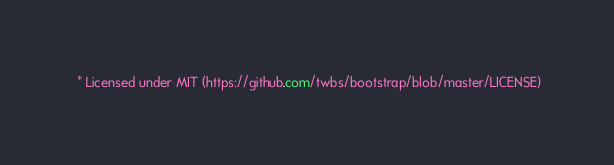<code> <loc_0><loc_0><loc_500><loc_500><_CSS_> * Licensed under MIT (https://github.com/twbs/bootstrap/blob/master/LICENSE)</code> 